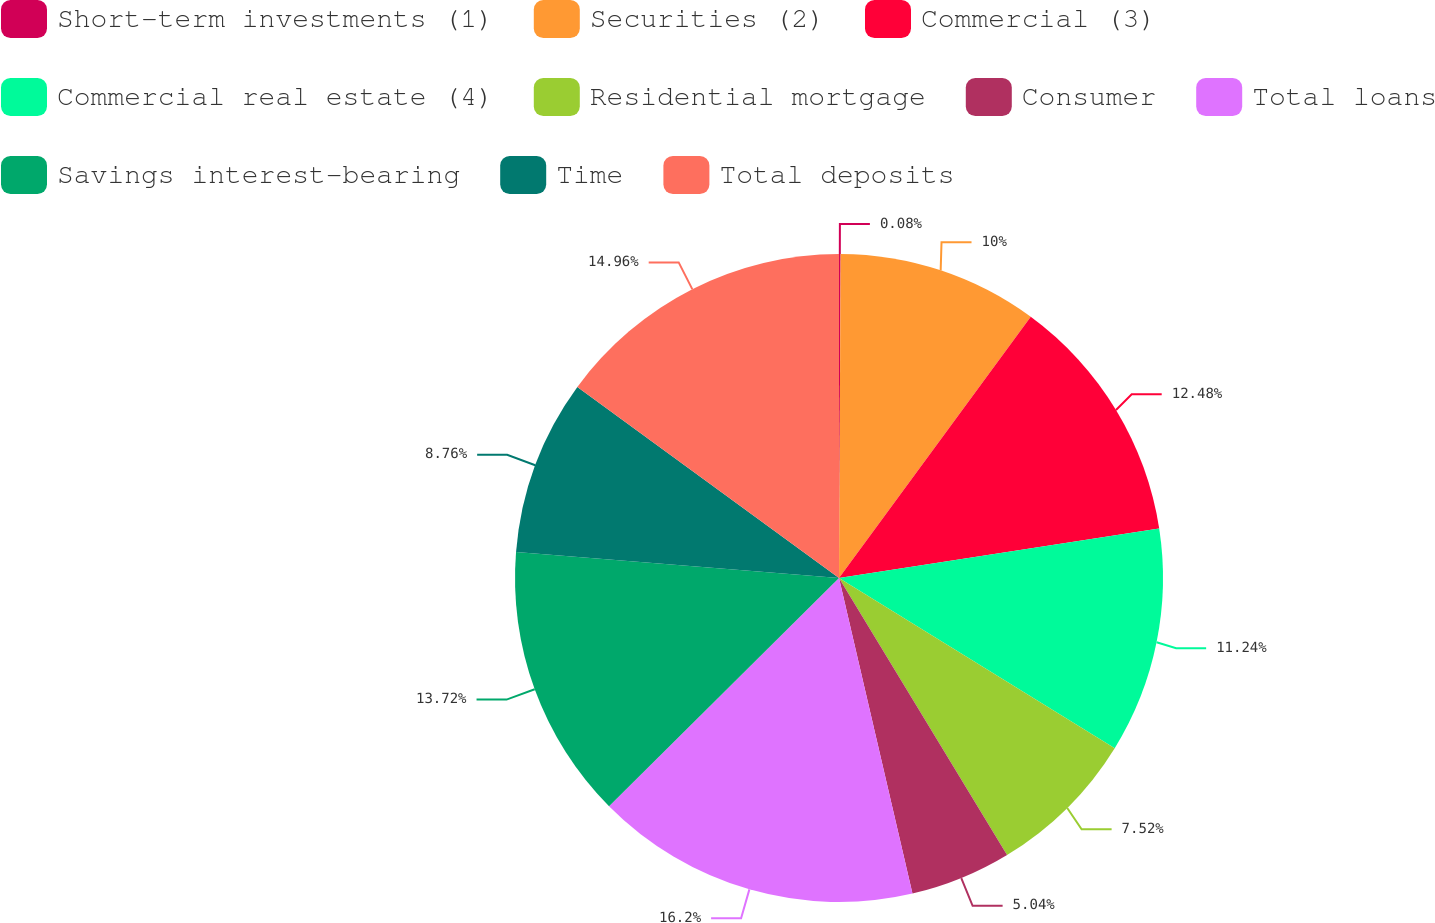Convert chart to OTSL. <chart><loc_0><loc_0><loc_500><loc_500><pie_chart><fcel>Short-term investments (1)<fcel>Securities (2)<fcel>Commercial (3)<fcel>Commercial real estate (4)<fcel>Residential mortgage<fcel>Consumer<fcel>Total loans<fcel>Savings interest-bearing<fcel>Time<fcel>Total deposits<nl><fcel>0.08%<fcel>10.0%<fcel>12.48%<fcel>11.24%<fcel>7.52%<fcel>5.04%<fcel>16.2%<fcel>13.72%<fcel>8.76%<fcel>14.96%<nl></chart> 